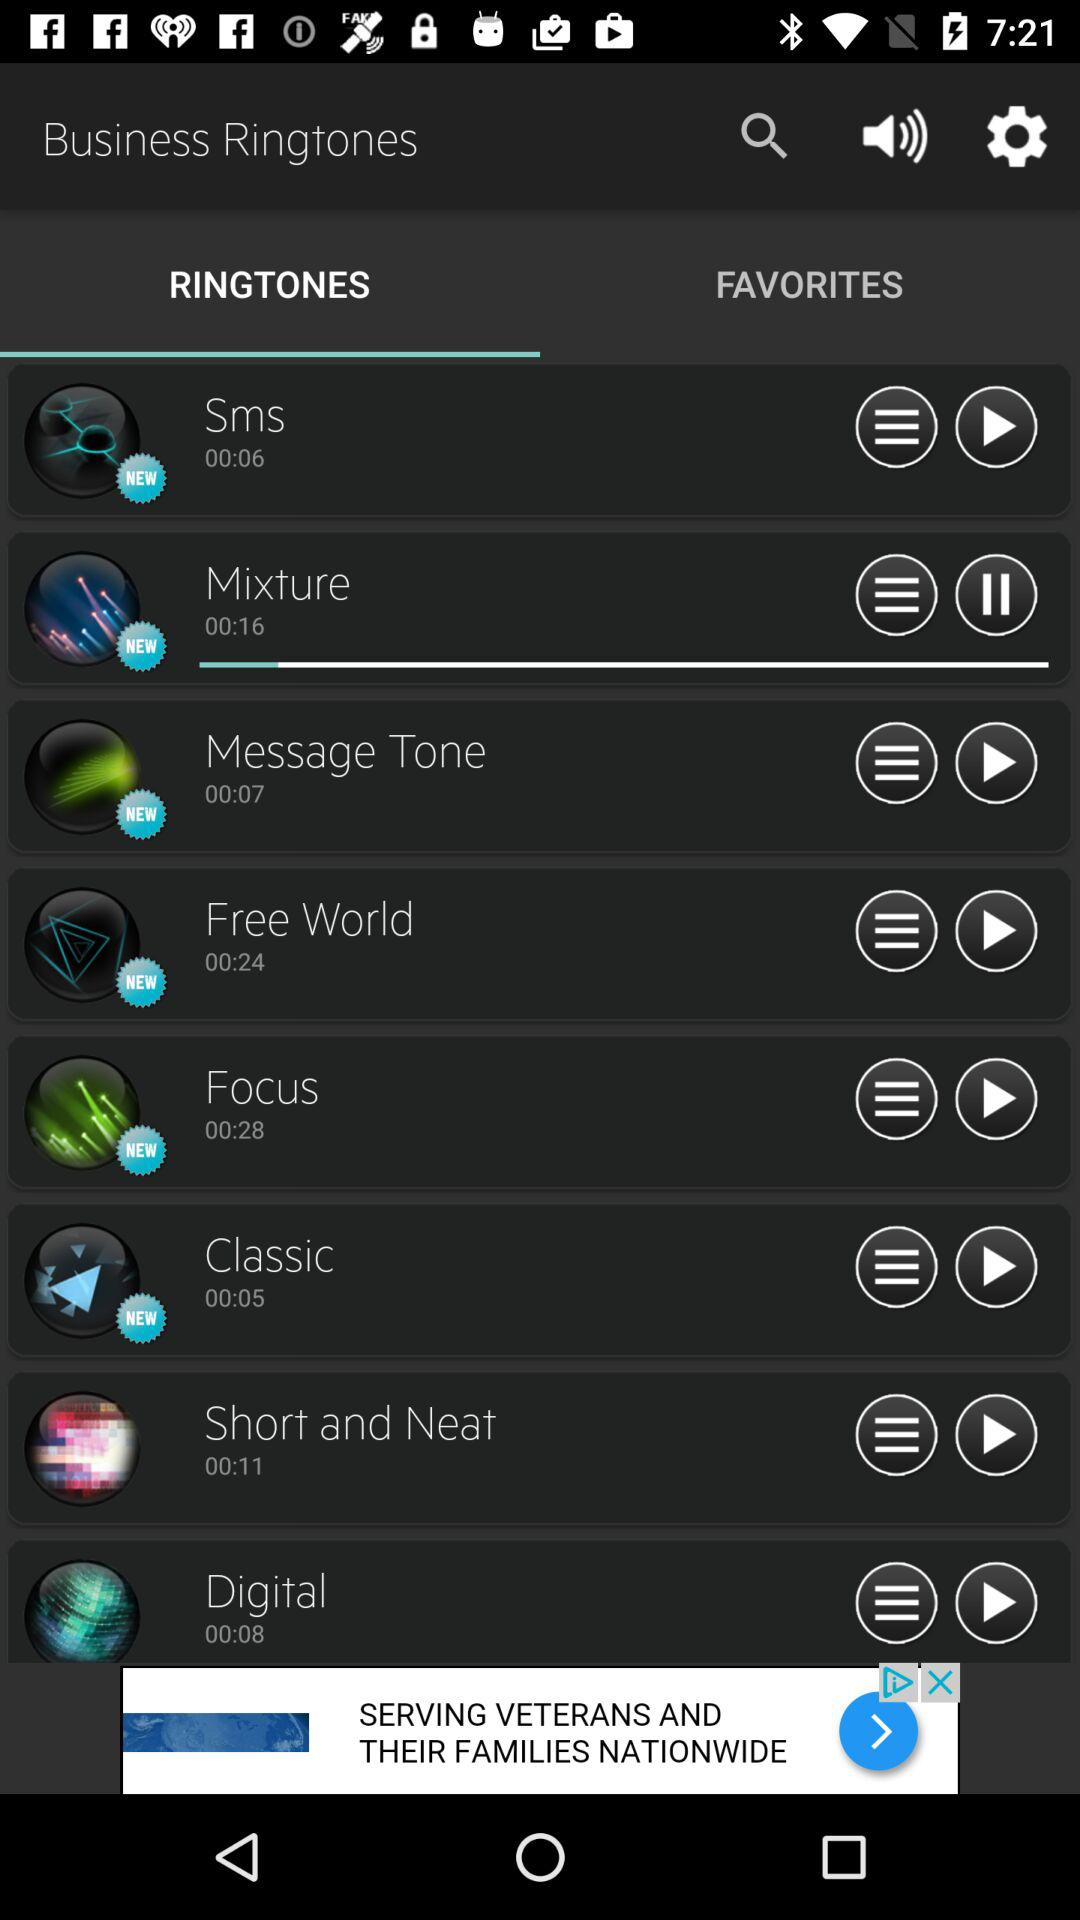Which tab is selected? The selected tab is "RINGTONES". 